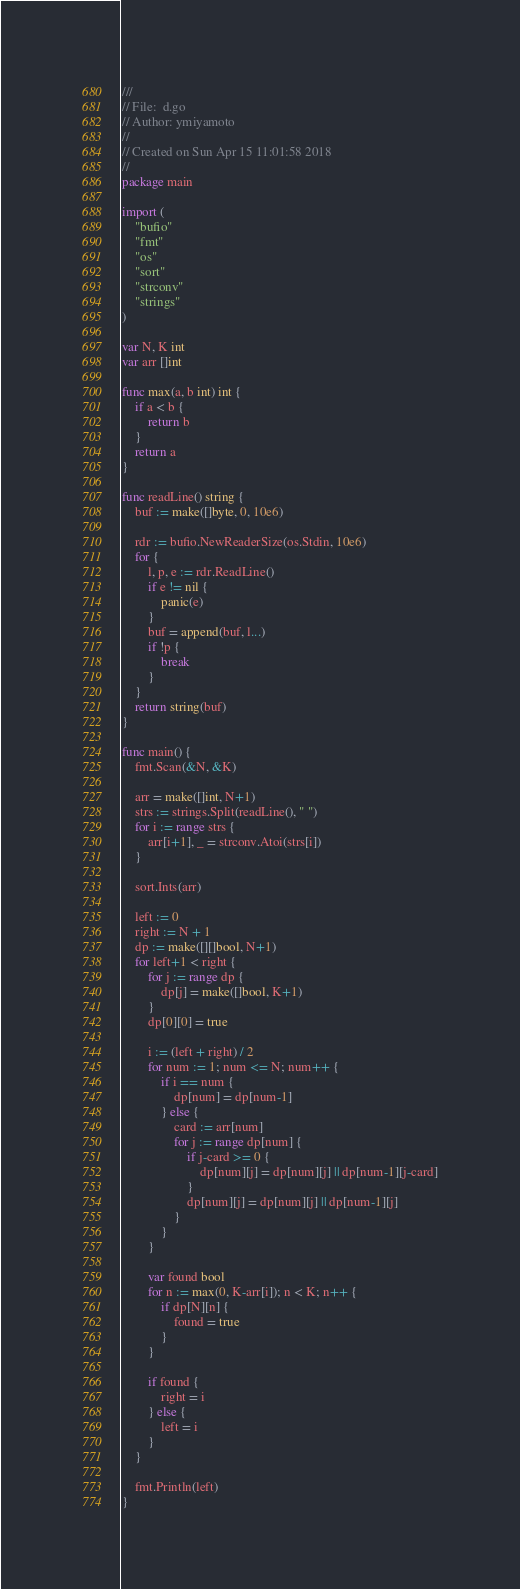Convert code to text. <code><loc_0><loc_0><loc_500><loc_500><_Go_>///
// File:  d.go
// Author: ymiyamoto
//
// Created on Sun Apr 15 11:01:58 2018
//
package main

import (
	"bufio"
	"fmt"
	"os"
	"sort"
	"strconv"
	"strings"
)

var N, K int
var arr []int

func max(a, b int) int {
	if a < b {
		return b
	}
	return a
}

func readLine() string {
	buf := make([]byte, 0, 10e6)

	rdr := bufio.NewReaderSize(os.Stdin, 10e6)
	for {
		l, p, e := rdr.ReadLine()
		if e != nil {
			panic(e)
		}
		buf = append(buf, l...)
		if !p {
			break
		}
	}
	return string(buf)
}

func main() {
	fmt.Scan(&N, &K)

	arr = make([]int, N+1)
	strs := strings.Split(readLine(), " ")
	for i := range strs {
		arr[i+1], _ = strconv.Atoi(strs[i])
	}

	sort.Ints(arr)

	left := 0
	right := N + 1
	dp := make([][]bool, N+1)
	for left+1 < right {
		for j := range dp {
			dp[j] = make([]bool, K+1)
		}
		dp[0][0] = true

		i := (left + right) / 2
		for num := 1; num <= N; num++ {
			if i == num {
				dp[num] = dp[num-1]
			} else {
				card := arr[num]
				for j := range dp[num] {
					if j-card >= 0 {
						dp[num][j] = dp[num][j] || dp[num-1][j-card]
					}
					dp[num][j] = dp[num][j] || dp[num-1][j]
				}
			}
		}

		var found bool
		for n := max(0, K-arr[i]); n < K; n++ {
			if dp[N][n] {
				found = true
			}
		}

		if found {
			right = i
		} else {
			left = i
		}
	}

	fmt.Println(left)
}
</code> 